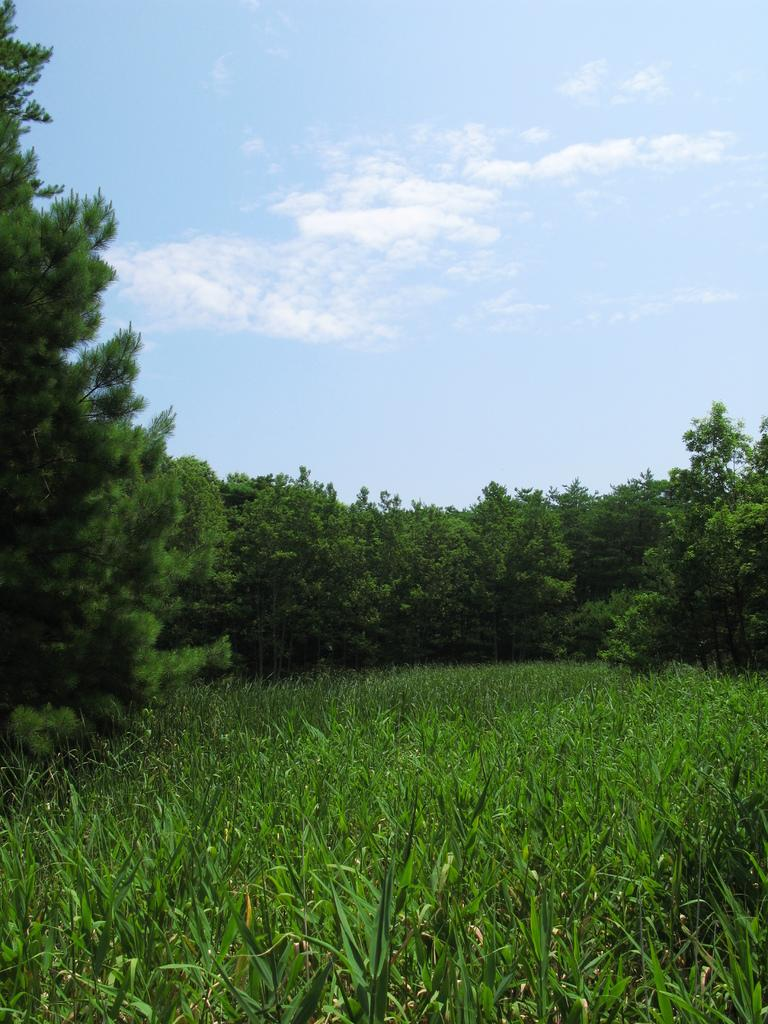What type of vegetation can be seen in the image? There are trees in the image. What is visible at the top of the image? The sky is visible at the top of the image. What can be seen in the sky? There are clouds in the sky. What type of vegetation is at the bottom of the image? There are plants at the bottom of the image. What religious beliefs are represented by the trees in the image? There is no indication of any religious beliefs in the image; it simply features trees and a sky with clouds. How many feet are visible in the image? There are no feet visible in the image. 